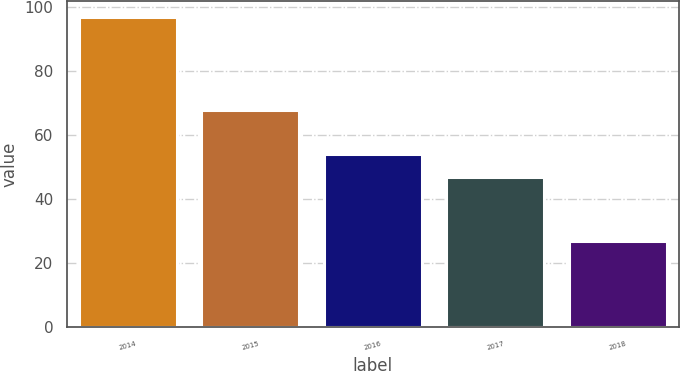Convert chart to OTSL. <chart><loc_0><loc_0><loc_500><loc_500><bar_chart><fcel>2014<fcel>2015<fcel>2016<fcel>2017<fcel>2018<nl><fcel>97<fcel>68<fcel>54<fcel>47<fcel>27<nl></chart> 